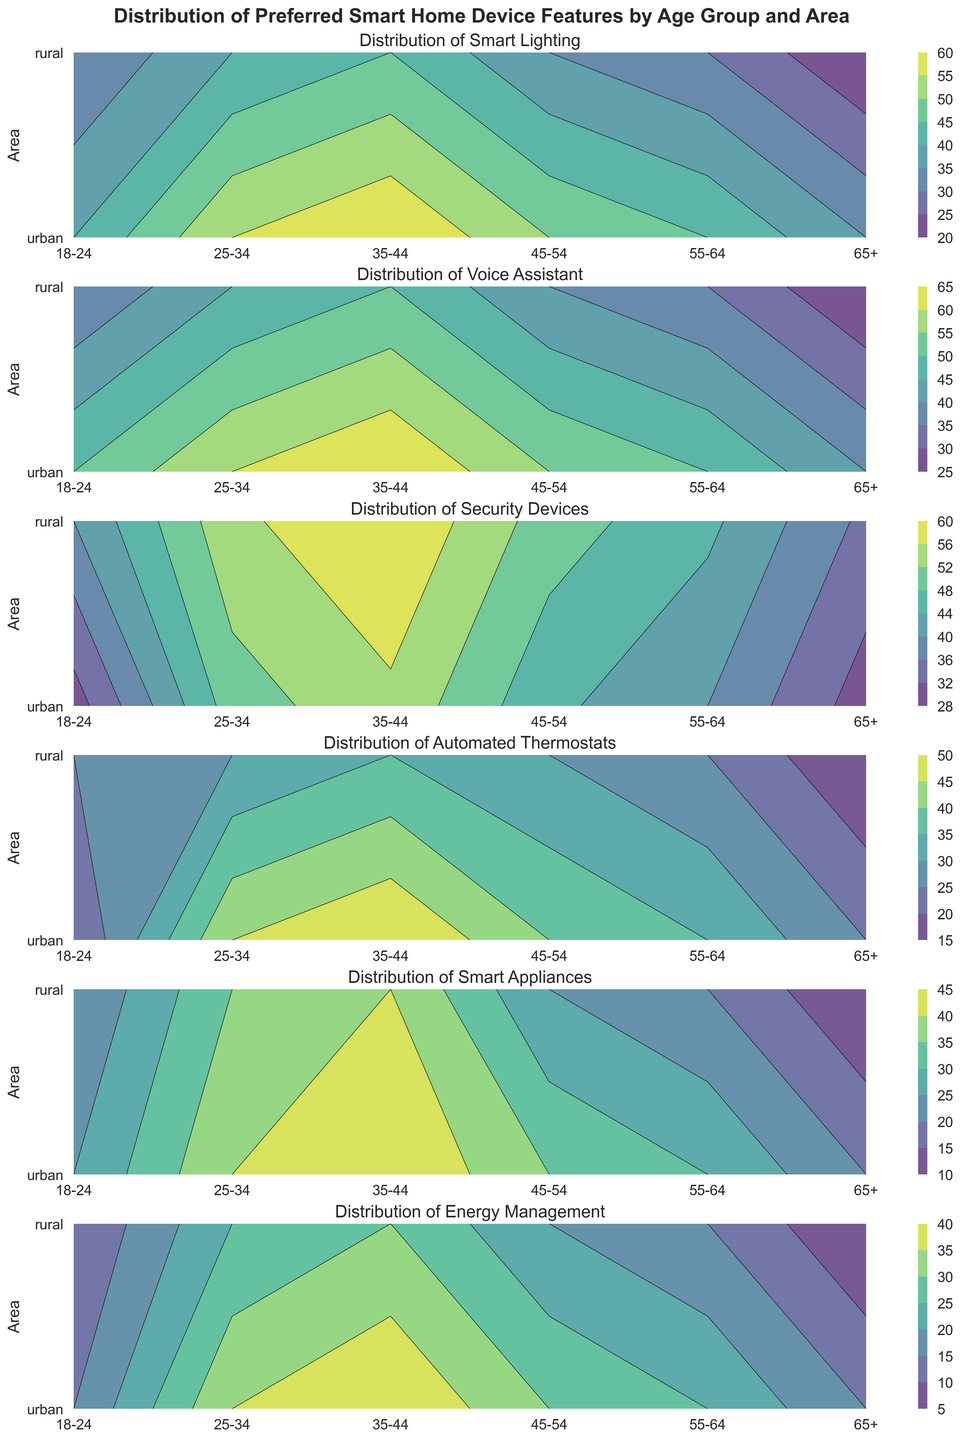How does the preference for voice assistants compare between the 18-24 age group in urban areas and rural areas? Look at the contour levels for voice assistants for the 18-24 age group and compare urban and rural areas. For urban, it's 50, and for rural, it’s 35.
Answer: Urban: 50, Rural: 35 Which age group in urban areas shows the highest preference for smart appliances? Examine the contours for smart appliances in urban areas across all age groups. The highest contour level is 45 for the 35-44 age group.
Answer: 35-44 Is the preference for energy management higher in urban or rural areas for the 25-34 age group? Look at the contour levels for energy management for the 25-34 age group in both urban and rural areas. For urban, it's 35, and for rural, it’s 25.
Answer: Urban What is the combined preference for security devices for the 45-54 age group across both urban and rural areas? Add the contour levels for security devices for the 45-54 age group in urban (45) and rural (50) areas.
Answer: 45 + 50 = 95 In which area do people aged 65+ prefer automated thermostats more, and by how much? Compare the contour levels for automated thermostats for the 65+ age group in both urban (25) and rural (15) areas. Calculate the difference.
Answer: Urban by 10 Which feature has the smallest difference in preference between urban and rural areas for the 35-44 age group? Calculate the differences for each feature in the 35-44 age group between urban and rural areas. Only the smallest one is energy management with 10 (40-30).
Answer: Energy management What is the average preference for smart lighting in rural areas across all age groups? Add the contour levels for smart lighting in rural areas across all age groups and divide by the number of age groups. (30 + 40 + 45 + 35 + 30 + 20) / 6 = 200 / 6
Answer: ~33.3 Which area and age group combination exhibits the highest preference for security devices? Identify the highest contour level in the security devices plot across all groups. The highest preference level is 60 for the 35-44 age group in rural areas.
Answer: Rural 35-44 Is the difference in preference for smart appliances between urban and rural areas greater for the 25-34 age group or the 55-64 age group? Calculate the differences for smart appliances between urban and rural areas for both age groups. For 25-34, it's 40 - 35 = 5. For 55-64, it's 30 - 20 = 10.
Answer: 55-64 age group Which feature shows the least variation in preference across the 18-24 age group in both urban and rural areas? Calculate the differences for each feature in the 18-24 age group between urban and rural areas. The smallest difference is 10 for all features except voice assistants (15).
Answer: Smart lighting, security devices, automated thermostats, smart appliances, energy management 